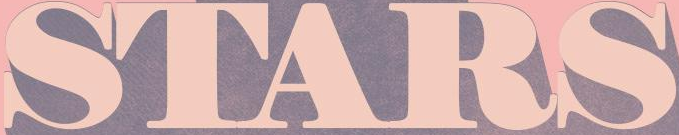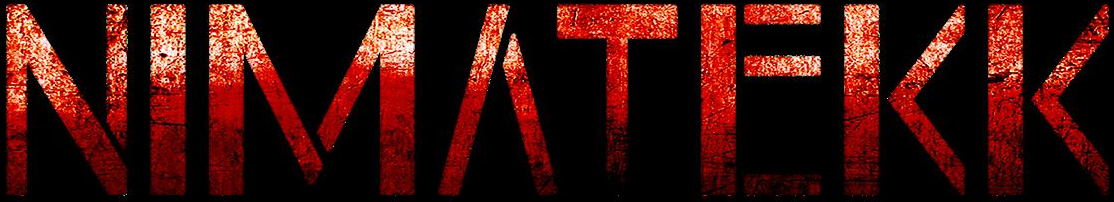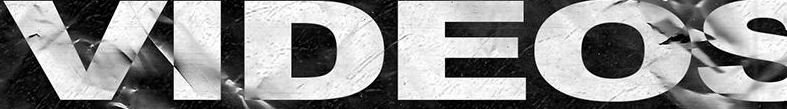What text is displayed in these images sequentially, separated by a semicolon? STARS; NIMΛTEKK; VIDEOS 